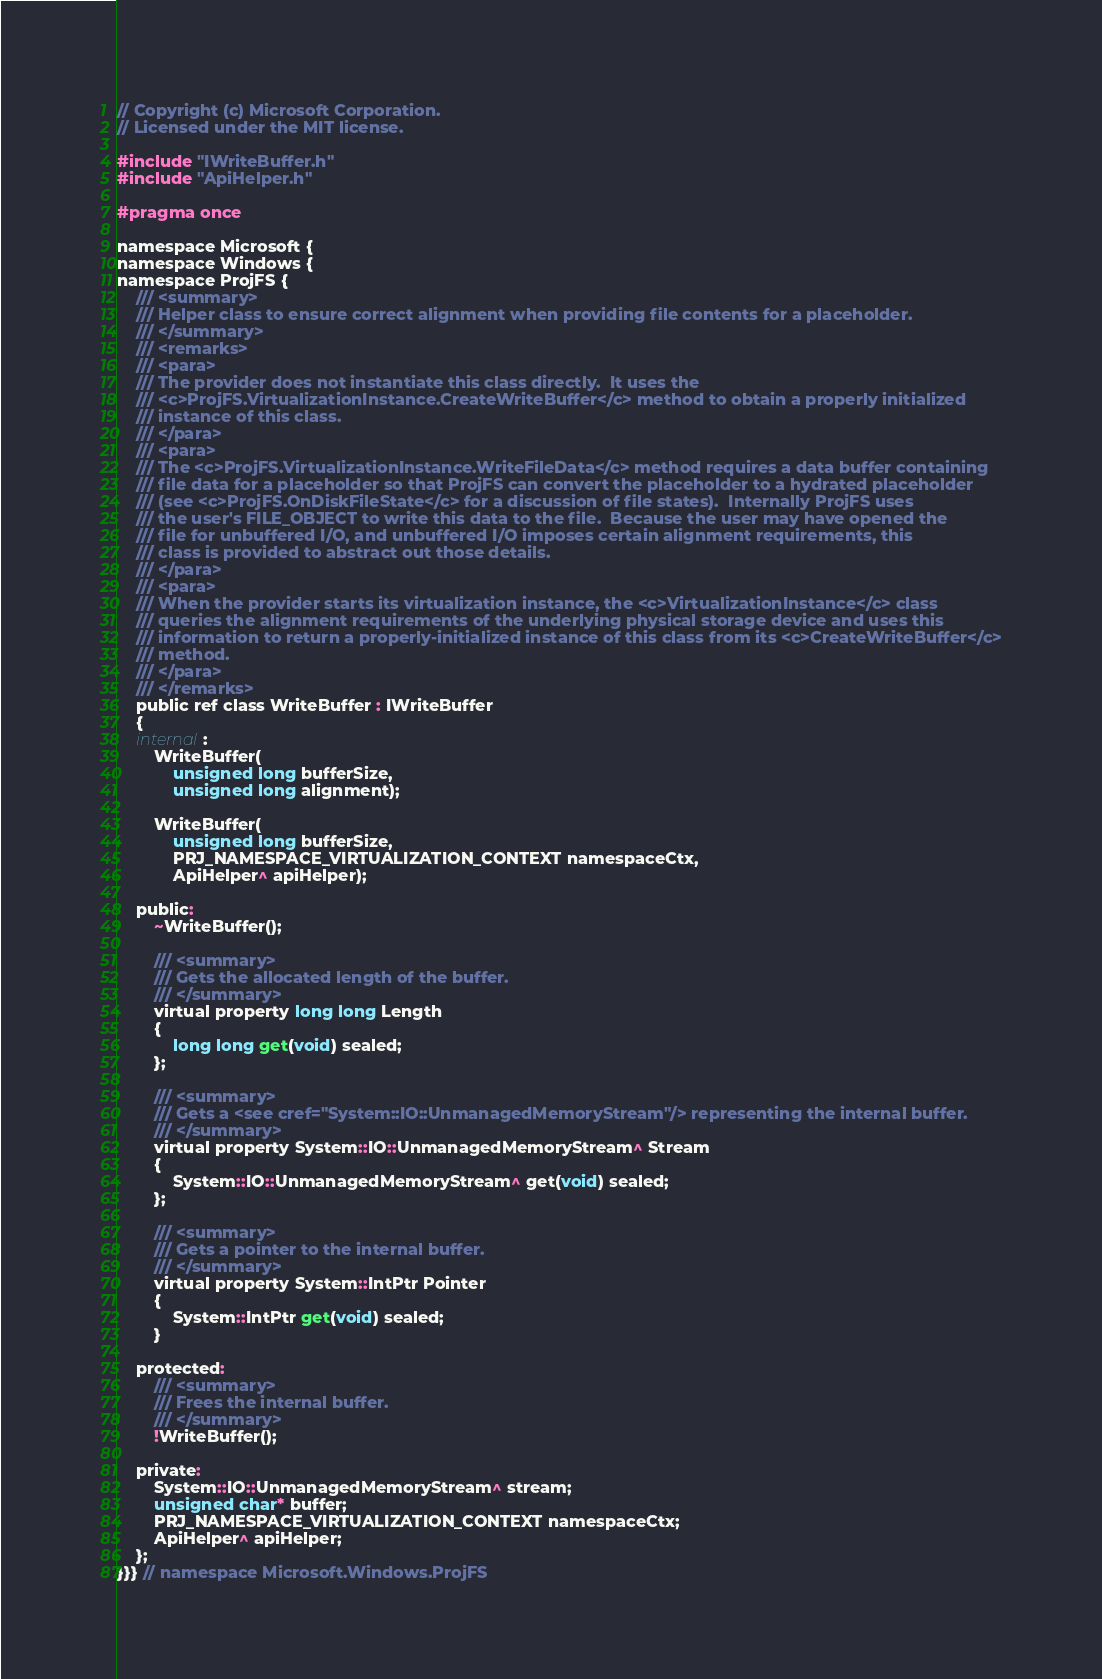Convert code to text. <code><loc_0><loc_0><loc_500><loc_500><_C_>// Copyright (c) Microsoft Corporation.
// Licensed under the MIT license.

#include "IWriteBuffer.h"
#include "ApiHelper.h"

#pragma once

namespace Microsoft {
namespace Windows {
namespace ProjFS {
    /// <summary>
    /// Helper class to ensure correct alignment when providing file contents for a placeholder.
    /// </summary>
    /// <remarks>
    /// <para>
    /// The provider does not instantiate this class directly.  It uses the 
    /// <c>ProjFS.VirtualizationInstance.CreateWriteBuffer</c> method to obtain a properly initialized
    /// instance of this class.
    /// </para>
    /// <para>
    /// The <c>ProjFS.VirtualizationInstance.WriteFileData</c> method requires a data buffer containing
    /// file data for a placeholder so that ProjFS can convert the placeholder to a hydrated placeholder
    /// (see <c>ProjFS.OnDiskFileState</c> for a discussion of file states).  Internally ProjFS uses
    /// the user's FILE_OBJECT to write this data to the file.  Because the user may have opened the
    /// file for unbuffered I/O, and unbuffered I/O imposes certain alignment requirements, this
    /// class is provided to abstract out those details.
    /// </para>
    /// <para>
    /// When the provider starts its virtualization instance, the <c>VirtualizationInstance</c> class
    /// queries the alignment requirements of the underlying physical storage device and uses this
    /// information to return a properly-initialized instance of this class from its <c>CreateWriteBuffer</c>
    /// method.
    /// </para>
    /// </remarks>
    public ref class WriteBuffer : IWriteBuffer
    {
    internal:
        WriteBuffer(
            unsigned long bufferSize,
            unsigned long alignment);

        WriteBuffer(
            unsigned long bufferSize,
            PRJ_NAMESPACE_VIRTUALIZATION_CONTEXT namespaceCtx,
            ApiHelper^ apiHelper);

    public:
        ~WriteBuffer();

        /// <summary>
        /// Gets the allocated length of the buffer.
        /// </summary>
        virtual property long long Length
        {
            long long get(void) sealed;
        };

        /// <summary>
        /// Gets a <see cref="System::IO::UnmanagedMemoryStream"/> representing the internal buffer.
        /// </summary>
        virtual property System::IO::UnmanagedMemoryStream^ Stream
        {
            System::IO::UnmanagedMemoryStream^ get(void) sealed;
        };

        /// <summary>
        /// Gets a pointer to the internal buffer.
        /// </summary>
        virtual property System::IntPtr Pointer
        {
            System::IntPtr get(void) sealed;
        }

    protected:
        /// <summary>
        /// Frees the internal buffer.
        /// </summary>
        !WriteBuffer();

    private:
        System::IO::UnmanagedMemoryStream^ stream;
        unsigned char* buffer;
        PRJ_NAMESPACE_VIRTUALIZATION_CONTEXT namespaceCtx;
        ApiHelper^ apiHelper;
    };
}}} // namespace Microsoft.Windows.ProjFS</code> 